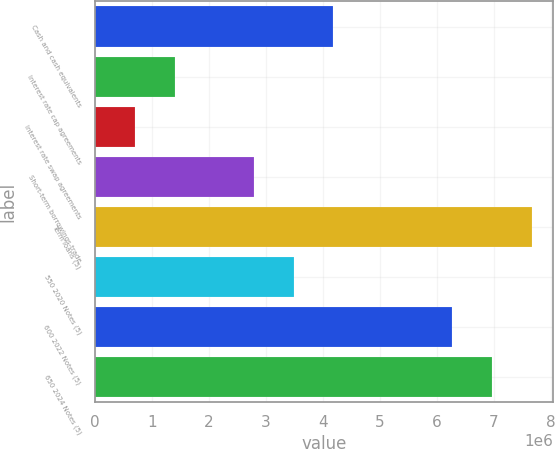<chart> <loc_0><loc_0><loc_500><loc_500><bar_chart><fcel>Cash and cash equivalents<fcel>Interest rate cap agreements<fcel>Interest rate swap agreements<fcel>Short-term borrowings-trade<fcel>Term loans (5)<fcel>550 2020 Notes (5)<fcel>600 2022 Notes (5)<fcel>650 2024 Notes (5)<nl><fcel>4.18054e+06<fcel>1.39545e+06<fcel>699177<fcel>2.78799e+06<fcel>7.6619e+06<fcel>3.48427e+06<fcel>6.26936e+06<fcel>6.96563e+06<nl></chart> 